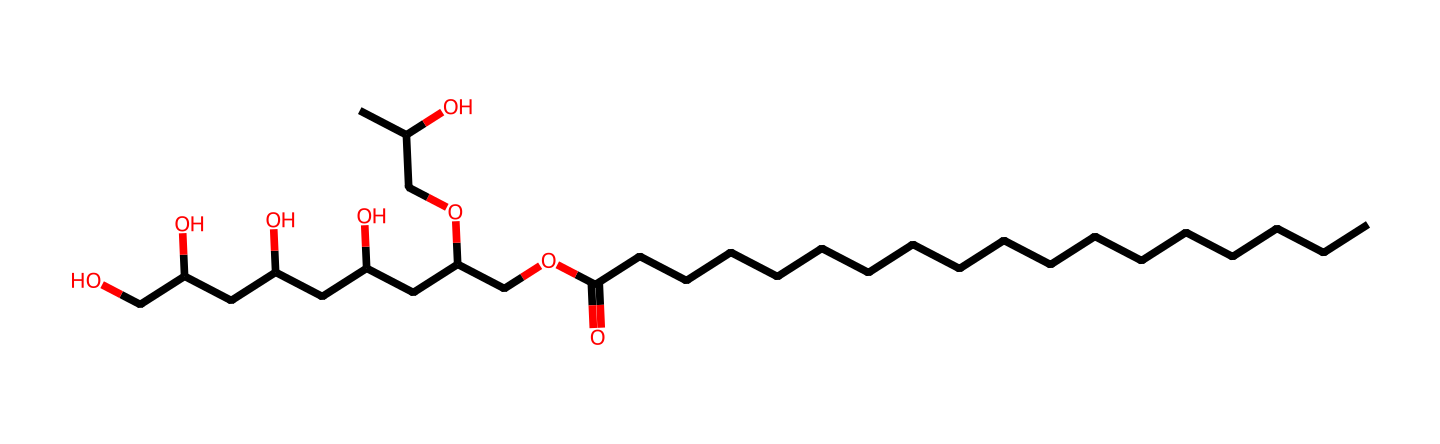What is the molecular formula of polysorbate 80? The molecular formula can be determined by counting the number of each type of atom in the SMILES representation. In the provided SMILES, there are 20 carbon (C) atoms, 42 hydrogen (H) atoms, and 10 oxygen (O) atoms. Therefore, the molecular formula is C20H42O10.
Answer: C20H42O10 How many oxygen atoms are present in polysorbate 80? By analyzing the SMILES representation, we can count the number of oxygen (O) atoms explicitly shown. There are 10 instances of O in the structure, indicating a total of 10 oxygen atoms.
Answer: 10 What is the longest carbon chain in polysorbate 80? The longest carbon chain can be identified by following consecutive carbon atoms in the main structure. In this SMILES, the longest chain is 18 carbon atoms long before branching occurs.
Answer: 18 What functional group is present in polysorbate 80? By examining the SMILES, we can observe various functional groups. Specifically, the presence of the carboxylic acid group (-COOH) can be identified at the carbon chain's end, along with several hydroxyl groups (-OH).
Answer: carboxylic acid Does polysorbate 80 contain any double bonds? The presence of double bonds can be determined by looking for "=" symbols in the SMILES representation. In this case, there is one double bond indicated between the carbon and oxygen, which confirms its presence.
Answer: yes What is the characteristic property of polysorbate 80 that makes it a surfactant? Polysorbate 80 possesses both hydrophilic and hydrophobic parts due to the long carbon chain and hydroxyl groups, making it able to reduce surface tension and stabilize emulsions.
Answer: amphiphilic How many branching points are in the structure of polysorbate 80? To identify branching points, we look for carbon atoms that connect to more than two other carbon atoms. In this structure, there are multiple branching points visible, totaling 5 distinct branches.
Answer: 5 